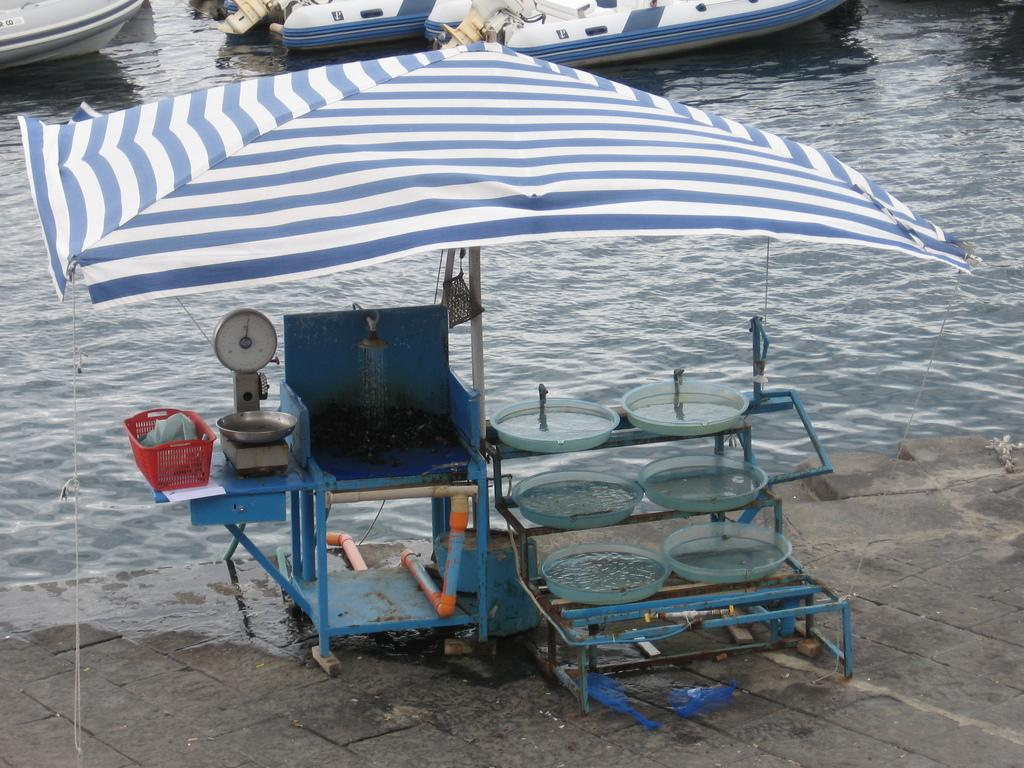What is located in the foreground of the picture? In the foreground of the picture, there is a chair, plates, an umbrella, a weighing machine, and a basket. Can you describe the objects in the foreground of the picture? There are plates, an umbrella, a weighing machine, and a basket in the foreground of the picture. What can be seen in the center of the picture? There are boats in the water in the center of the picture. Are there any other objects in the foreground of the picture besides the ones mentioned? Yes, there are other objects in the foreground of the picture. What type of tax is being collected from the boats in the image? There is no indication in the image that any tax is being collected from the boats. What error can be seen in the umbrella's design in the image? There is no umbrella present in the image, so it is not possible to assess its design or identify any errors. 